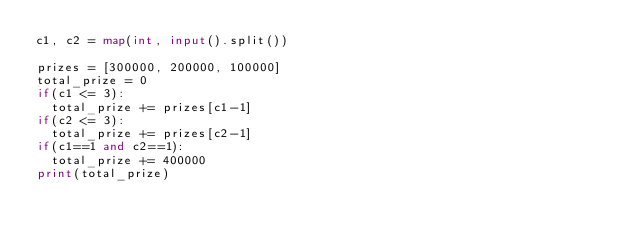Convert code to text. <code><loc_0><loc_0><loc_500><loc_500><_Python_>c1, c2 = map(int, input().split())

prizes = [300000, 200000, 100000]
total_prize = 0
if(c1 <= 3):
  total_prize += prizes[c1-1]
if(c2 <= 3):
  total_prize += prizes[c2-1]
if(c1==1 and c2==1):
  total_prize += 400000
print(total_prize)</code> 